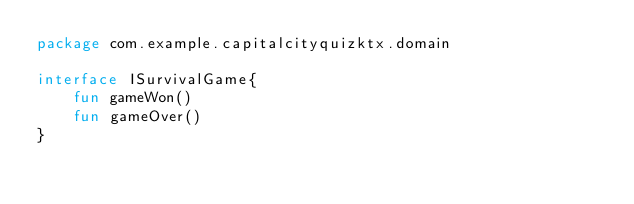<code> <loc_0><loc_0><loc_500><loc_500><_Kotlin_>package com.example.capitalcityquizktx.domain

interface ISurvivalGame{
    fun gameWon()
    fun gameOver()
}</code> 